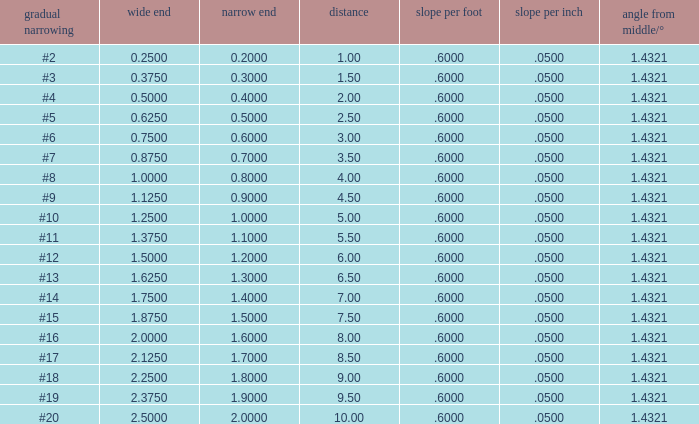Which Taper/ft that has a Large end smaller than 0.5, and a Taper of #2? 0.6. 